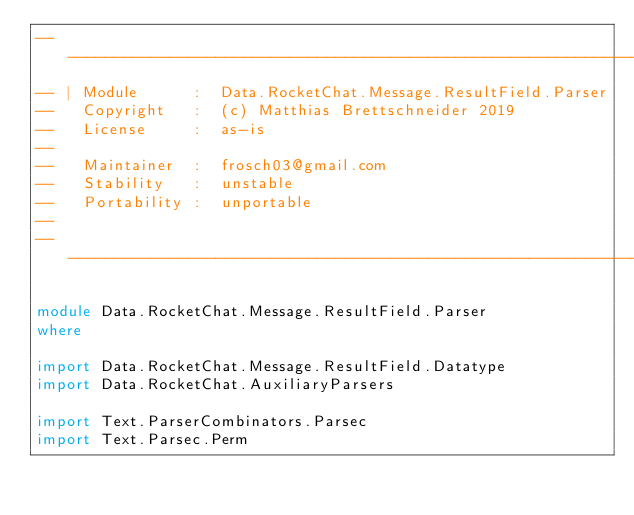Convert code to text. <code><loc_0><loc_0><loc_500><loc_500><_Haskell_>-------------------------------------------------------------------------------
-- | Module      :  Data.RocketChat.Message.ResultField.Parser
--   Copyright   :  (c) Matthias Brettschneider 2019
--   License     :  as-is
--
--   Maintainer  :  frosch03@gmail.com
--   Stability   :  unstable
--   Portability :  unportable
--
-------------------------------------------------------------------------------

module Data.RocketChat.Message.ResultField.Parser
where

import Data.RocketChat.Message.ResultField.Datatype
import Data.RocketChat.AuxiliaryParsers

import Text.ParserCombinators.Parsec
import Text.Parsec.Perm
</code> 